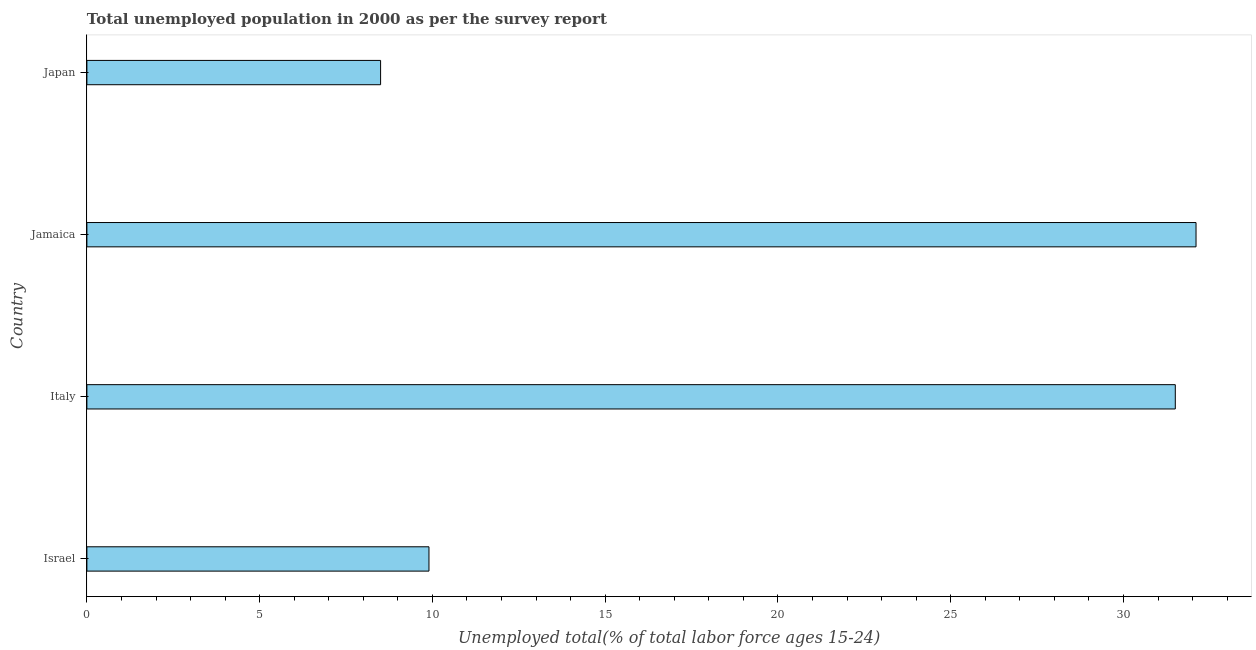Does the graph contain any zero values?
Give a very brief answer. No. Does the graph contain grids?
Make the answer very short. No. What is the title of the graph?
Offer a very short reply. Total unemployed population in 2000 as per the survey report. What is the label or title of the X-axis?
Provide a short and direct response. Unemployed total(% of total labor force ages 15-24). What is the label or title of the Y-axis?
Provide a short and direct response. Country. What is the unemployed youth in Japan?
Provide a succinct answer. 8.5. Across all countries, what is the maximum unemployed youth?
Make the answer very short. 32.1. Across all countries, what is the minimum unemployed youth?
Keep it short and to the point. 8.5. In which country was the unemployed youth maximum?
Your answer should be very brief. Jamaica. What is the sum of the unemployed youth?
Provide a succinct answer. 82. What is the difference between the unemployed youth in Jamaica and Japan?
Make the answer very short. 23.6. What is the average unemployed youth per country?
Offer a terse response. 20.5. What is the median unemployed youth?
Ensure brevity in your answer.  20.7. In how many countries, is the unemployed youth greater than 13 %?
Ensure brevity in your answer.  2. What is the ratio of the unemployed youth in Israel to that in Jamaica?
Make the answer very short. 0.31. Is the unemployed youth in Italy less than that in Japan?
Ensure brevity in your answer.  No. Is the difference between the unemployed youth in Italy and Japan greater than the difference between any two countries?
Offer a very short reply. No. Is the sum of the unemployed youth in Israel and Japan greater than the maximum unemployed youth across all countries?
Offer a terse response. No. What is the difference between the highest and the lowest unemployed youth?
Offer a very short reply. 23.6. What is the Unemployed total(% of total labor force ages 15-24) in Israel?
Your answer should be compact. 9.9. What is the Unemployed total(% of total labor force ages 15-24) of Italy?
Give a very brief answer. 31.5. What is the Unemployed total(% of total labor force ages 15-24) of Jamaica?
Your answer should be compact. 32.1. What is the Unemployed total(% of total labor force ages 15-24) in Japan?
Offer a very short reply. 8.5. What is the difference between the Unemployed total(% of total labor force ages 15-24) in Israel and Italy?
Keep it short and to the point. -21.6. What is the difference between the Unemployed total(% of total labor force ages 15-24) in Israel and Jamaica?
Provide a succinct answer. -22.2. What is the difference between the Unemployed total(% of total labor force ages 15-24) in Jamaica and Japan?
Ensure brevity in your answer.  23.6. What is the ratio of the Unemployed total(% of total labor force ages 15-24) in Israel to that in Italy?
Keep it short and to the point. 0.31. What is the ratio of the Unemployed total(% of total labor force ages 15-24) in Israel to that in Jamaica?
Your answer should be compact. 0.31. What is the ratio of the Unemployed total(% of total labor force ages 15-24) in Israel to that in Japan?
Provide a short and direct response. 1.17. What is the ratio of the Unemployed total(% of total labor force ages 15-24) in Italy to that in Japan?
Your response must be concise. 3.71. What is the ratio of the Unemployed total(% of total labor force ages 15-24) in Jamaica to that in Japan?
Give a very brief answer. 3.78. 